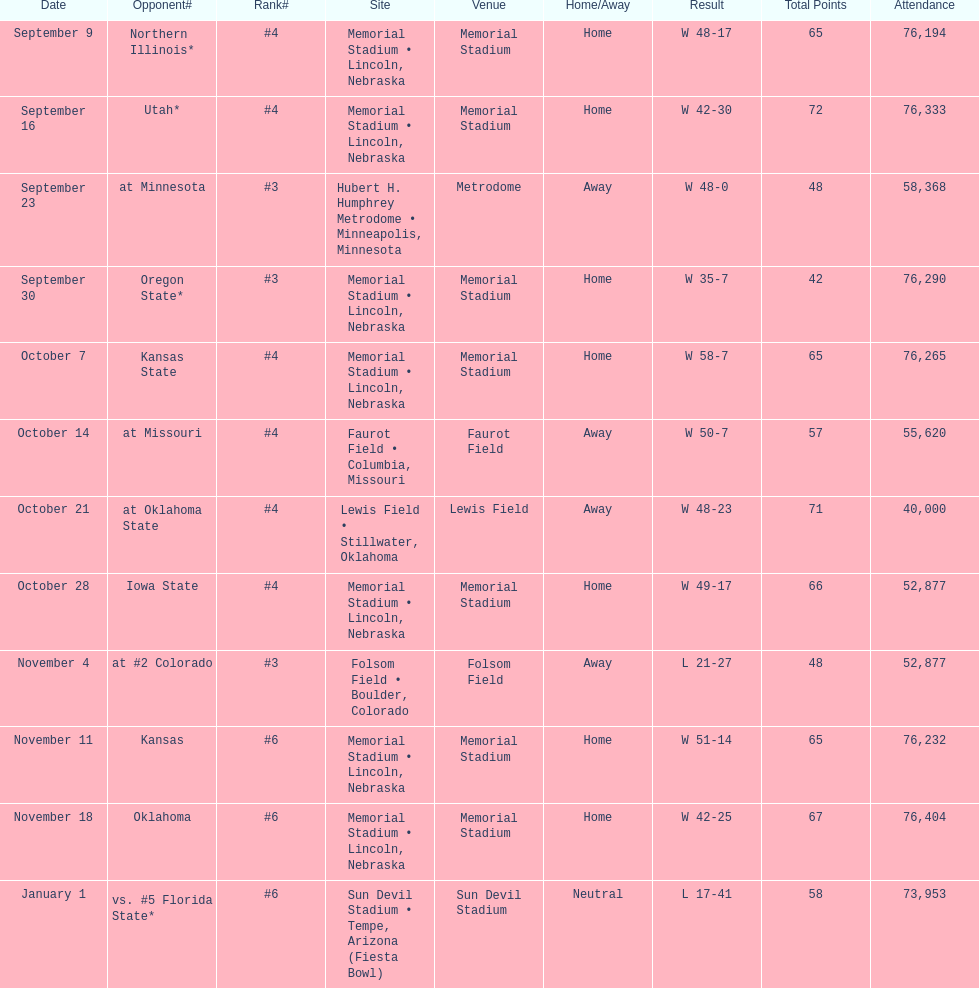How many games did they win by more than 7? 10. 